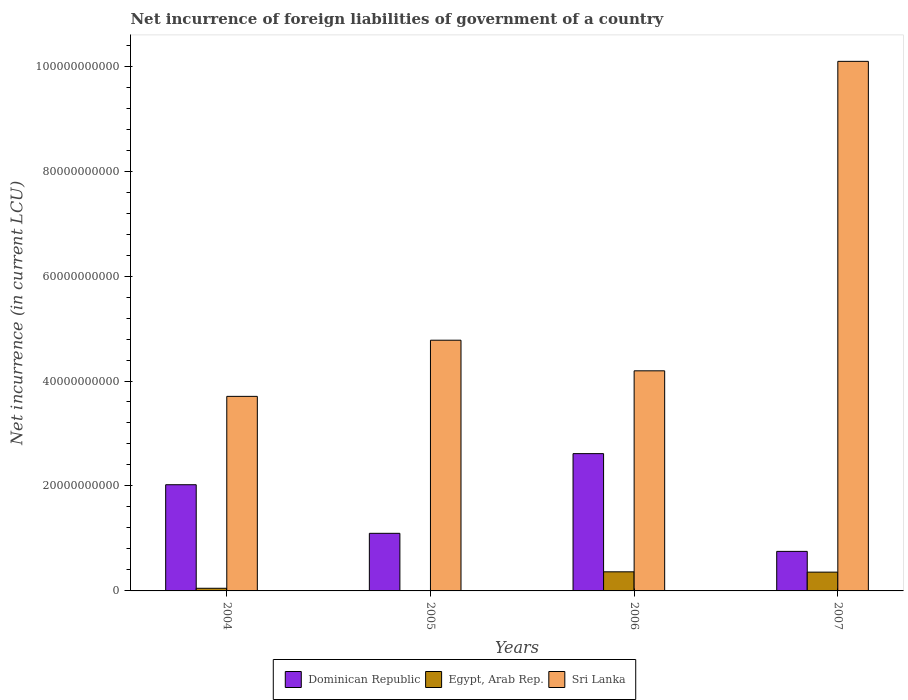How many groups of bars are there?
Your response must be concise. 4. Are the number of bars per tick equal to the number of legend labels?
Offer a very short reply. No. How many bars are there on the 2nd tick from the left?
Give a very brief answer. 2. In how many cases, is the number of bars for a given year not equal to the number of legend labels?
Make the answer very short. 1. What is the net incurrence of foreign liabilities in Dominican Republic in 2005?
Offer a terse response. 1.10e+1. Across all years, what is the maximum net incurrence of foreign liabilities in Dominican Republic?
Give a very brief answer. 2.62e+1. Across all years, what is the minimum net incurrence of foreign liabilities in Sri Lanka?
Provide a succinct answer. 3.71e+1. What is the total net incurrence of foreign liabilities in Dominican Republic in the graph?
Keep it short and to the point. 6.49e+1. What is the difference between the net incurrence of foreign liabilities in Sri Lanka in 2004 and that in 2007?
Offer a terse response. -6.38e+1. What is the difference between the net incurrence of foreign liabilities in Dominican Republic in 2005 and the net incurrence of foreign liabilities in Egypt, Arab Rep. in 2004?
Make the answer very short. 1.05e+1. What is the average net incurrence of foreign liabilities in Egypt, Arab Rep. per year?
Your response must be concise. 1.93e+09. In the year 2005, what is the difference between the net incurrence of foreign liabilities in Sri Lanka and net incurrence of foreign liabilities in Dominican Republic?
Provide a short and direct response. 3.68e+1. What is the ratio of the net incurrence of foreign liabilities in Egypt, Arab Rep. in 2006 to that in 2007?
Your answer should be compact. 1.02. Is the net incurrence of foreign liabilities in Dominican Republic in 2004 less than that in 2006?
Ensure brevity in your answer.  Yes. Is the difference between the net incurrence of foreign liabilities in Sri Lanka in 2005 and 2006 greater than the difference between the net incurrence of foreign liabilities in Dominican Republic in 2005 and 2006?
Offer a very short reply. Yes. What is the difference between the highest and the second highest net incurrence of foreign liabilities in Dominican Republic?
Your response must be concise. 5.93e+09. What is the difference between the highest and the lowest net incurrence of foreign liabilities in Egypt, Arab Rep.?
Offer a very short reply. 3.64e+09. In how many years, is the net incurrence of foreign liabilities in Egypt, Arab Rep. greater than the average net incurrence of foreign liabilities in Egypt, Arab Rep. taken over all years?
Keep it short and to the point. 2. Is the sum of the net incurrence of foreign liabilities in Egypt, Arab Rep. in 2006 and 2007 greater than the maximum net incurrence of foreign liabilities in Dominican Republic across all years?
Your answer should be compact. No. How many bars are there?
Offer a very short reply. 11. Are the values on the major ticks of Y-axis written in scientific E-notation?
Keep it short and to the point. No. Does the graph contain any zero values?
Provide a succinct answer. Yes. Does the graph contain grids?
Your answer should be very brief. No. Where does the legend appear in the graph?
Your answer should be very brief. Bottom center. How are the legend labels stacked?
Offer a terse response. Horizontal. What is the title of the graph?
Your answer should be very brief. Net incurrence of foreign liabilities of government of a country. What is the label or title of the Y-axis?
Your answer should be very brief. Net incurrence (in current LCU). What is the Net incurrence (in current LCU) of Dominican Republic in 2004?
Offer a very short reply. 2.02e+1. What is the Net incurrence (in current LCU) in Egypt, Arab Rep. in 2004?
Offer a very short reply. 5.04e+08. What is the Net incurrence (in current LCU) in Sri Lanka in 2004?
Keep it short and to the point. 3.71e+1. What is the Net incurrence (in current LCU) of Dominican Republic in 2005?
Offer a very short reply. 1.10e+1. What is the Net incurrence (in current LCU) of Egypt, Arab Rep. in 2005?
Provide a short and direct response. 0. What is the Net incurrence (in current LCU) in Sri Lanka in 2005?
Offer a terse response. 4.78e+1. What is the Net incurrence (in current LCU) of Dominican Republic in 2006?
Your response must be concise. 2.62e+1. What is the Net incurrence (in current LCU) in Egypt, Arab Rep. in 2006?
Provide a short and direct response. 3.64e+09. What is the Net incurrence (in current LCU) in Sri Lanka in 2006?
Give a very brief answer. 4.19e+1. What is the Net incurrence (in current LCU) in Dominican Republic in 2007?
Your answer should be very brief. 7.53e+09. What is the Net incurrence (in current LCU) of Egypt, Arab Rep. in 2007?
Make the answer very short. 3.58e+09. What is the Net incurrence (in current LCU) in Sri Lanka in 2007?
Offer a terse response. 1.01e+11. Across all years, what is the maximum Net incurrence (in current LCU) of Dominican Republic?
Your response must be concise. 2.62e+1. Across all years, what is the maximum Net incurrence (in current LCU) in Egypt, Arab Rep.?
Give a very brief answer. 3.64e+09. Across all years, what is the maximum Net incurrence (in current LCU) of Sri Lanka?
Provide a short and direct response. 1.01e+11. Across all years, what is the minimum Net incurrence (in current LCU) in Dominican Republic?
Provide a short and direct response. 7.53e+09. Across all years, what is the minimum Net incurrence (in current LCU) in Egypt, Arab Rep.?
Give a very brief answer. 0. Across all years, what is the minimum Net incurrence (in current LCU) in Sri Lanka?
Offer a very short reply. 3.71e+1. What is the total Net incurrence (in current LCU) in Dominican Republic in the graph?
Provide a short and direct response. 6.49e+1. What is the total Net incurrence (in current LCU) in Egypt, Arab Rep. in the graph?
Make the answer very short. 7.73e+09. What is the total Net incurrence (in current LCU) of Sri Lanka in the graph?
Your answer should be compact. 2.28e+11. What is the difference between the Net incurrence (in current LCU) in Dominican Republic in 2004 and that in 2005?
Offer a very short reply. 9.26e+09. What is the difference between the Net incurrence (in current LCU) of Sri Lanka in 2004 and that in 2005?
Provide a short and direct response. -1.07e+1. What is the difference between the Net incurrence (in current LCU) of Dominican Republic in 2004 and that in 2006?
Offer a terse response. -5.93e+09. What is the difference between the Net incurrence (in current LCU) of Egypt, Arab Rep. in 2004 and that in 2006?
Give a very brief answer. -3.14e+09. What is the difference between the Net incurrence (in current LCU) in Sri Lanka in 2004 and that in 2006?
Give a very brief answer. -4.87e+09. What is the difference between the Net incurrence (in current LCU) of Dominican Republic in 2004 and that in 2007?
Offer a terse response. 1.27e+1. What is the difference between the Net incurrence (in current LCU) of Egypt, Arab Rep. in 2004 and that in 2007?
Give a very brief answer. -3.08e+09. What is the difference between the Net incurrence (in current LCU) in Sri Lanka in 2004 and that in 2007?
Offer a very short reply. -6.38e+1. What is the difference between the Net incurrence (in current LCU) of Dominican Republic in 2005 and that in 2006?
Offer a very short reply. -1.52e+1. What is the difference between the Net incurrence (in current LCU) in Sri Lanka in 2005 and that in 2006?
Your response must be concise. 5.83e+09. What is the difference between the Net incurrence (in current LCU) of Dominican Republic in 2005 and that in 2007?
Your answer should be compact. 3.44e+09. What is the difference between the Net incurrence (in current LCU) in Sri Lanka in 2005 and that in 2007?
Make the answer very short. -5.31e+1. What is the difference between the Net incurrence (in current LCU) in Dominican Republic in 2006 and that in 2007?
Your answer should be very brief. 1.86e+1. What is the difference between the Net incurrence (in current LCU) in Egypt, Arab Rep. in 2006 and that in 2007?
Provide a short and direct response. 6.00e+07. What is the difference between the Net incurrence (in current LCU) of Sri Lanka in 2006 and that in 2007?
Ensure brevity in your answer.  -5.90e+1. What is the difference between the Net incurrence (in current LCU) in Dominican Republic in 2004 and the Net incurrence (in current LCU) in Sri Lanka in 2005?
Your response must be concise. -2.75e+1. What is the difference between the Net incurrence (in current LCU) of Egypt, Arab Rep. in 2004 and the Net incurrence (in current LCU) of Sri Lanka in 2005?
Ensure brevity in your answer.  -4.73e+1. What is the difference between the Net incurrence (in current LCU) in Dominican Republic in 2004 and the Net incurrence (in current LCU) in Egypt, Arab Rep. in 2006?
Provide a succinct answer. 1.66e+1. What is the difference between the Net incurrence (in current LCU) of Dominican Republic in 2004 and the Net incurrence (in current LCU) of Sri Lanka in 2006?
Provide a short and direct response. -2.17e+1. What is the difference between the Net incurrence (in current LCU) in Egypt, Arab Rep. in 2004 and the Net incurrence (in current LCU) in Sri Lanka in 2006?
Keep it short and to the point. -4.14e+1. What is the difference between the Net incurrence (in current LCU) of Dominican Republic in 2004 and the Net incurrence (in current LCU) of Egypt, Arab Rep. in 2007?
Your response must be concise. 1.67e+1. What is the difference between the Net incurrence (in current LCU) in Dominican Republic in 2004 and the Net incurrence (in current LCU) in Sri Lanka in 2007?
Provide a short and direct response. -8.07e+1. What is the difference between the Net incurrence (in current LCU) of Egypt, Arab Rep. in 2004 and the Net incurrence (in current LCU) of Sri Lanka in 2007?
Ensure brevity in your answer.  -1.00e+11. What is the difference between the Net incurrence (in current LCU) of Dominican Republic in 2005 and the Net incurrence (in current LCU) of Egypt, Arab Rep. in 2006?
Provide a succinct answer. 7.34e+09. What is the difference between the Net incurrence (in current LCU) of Dominican Republic in 2005 and the Net incurrence (in current LCU) of Sri Lanka in 2006?
Your response must be concise. -3.10e+1. What is the difference between the Net incurrence (in current LCU) in Dominican Republic in 2005 and the Net incurrence (in current LCU) in Egypt, Arab Rep. in 2007?
Give a very brief answer. 7.40e+09. What is the difference between the Net incurrence (in current LCU) in Dominican Republic in 2005 and the Net incurrence (in current LCU) in Sri Lanka in 2007?
Provide a short and direct response. -8.99e+1. What is the difference between the Net incurrence (in current LCU) of Dominican Republic in 2006 and the Net incurrence (in current LCU) of Egypt, Arab Rep. in 2007?
Offer a very short reply. 2.26e+1. What is the difference between the Net incurrence (in current LCU) of Dominican Republic in 2006 and the Net incurrence (in current LCU) of Sri Lanka in 2007?
Your answer should be compact. -7.47e+1. What is the difference between the Net incurrence (in current LCU) in Egypt, Arab Rep. in 2006 and the Net incurrence (in current LCU) in Sri Lanka in 2007?
Your response must be concise. -9.73e+1. What is the average Net incurrence (in current LCU) of Dominican Republic per year?
Give a very brief answer. 1.62e+1. What is the average Net incurrence (in current LCU) in Egypt, Arab Rep. per year?
Your answer should be compact. 1.93e+09. What is the average Net incurrence (in current LCU) of Sri Lanka per year?
Offer a terse response. 5.69e+1. In the year 2004, what is the difference between the Net incurrence (in current LCU) in Dominican Republic and Net incurrence (in current LCU) in Egypt, Arab Rep.?
Keep it short and to the point. 1.97e+1. In the year 2004, what is the difference between the Net incurrence (in current LCU) of Dominican Republic and Net incurrence (in current LCU) of Sri Lanka?
Your answer should be compact. -1.68e+1. In the year 2004, what is the difference between the Net incurrence (in current LCU) of Egypt, Arab Rep. and Net incurrence (in current LCU) of Sri Lanka?
Your answer should be compact. -3.66e+1. In the year 2005, what is the difference between the Net incurrence (in current LCU) in Dominican Republic and Net incurrence (in current LCU) in Sri Lanka?
Keep it short and to the point. -3.68e+1. In the year 2006, what is the difference between the Net incurrence (in current LCU) of Dominican Republic and Net incurrence (in current LCU) of Egypt, Arab Rep.?
Your answer should be compact. 2.25e+1. In the year 2006, what is the difference between the Net incurrence (in current LCU) in Dominican Republic and Net incurrence (in current LCU) in Sri Lanka?
Offer a terse response. -1.58e+1. In the year 2006, what is the difference between the Net incurrence (in current LCU) in Egypt, Arab Rep. and Net incurrence (in current LCU) in Sri Lanka?
Your response must be concise. -3.83e+1. In the year 2007, what is the difference between the Net incurrence (in current LCU) in Dominican Republic and Net incurrence (in current LCU) in Egypt, Arab Rep.?
Offer a very short reply. 3.95e+09. In the year 2007, what is the difference between the Net incurrence (in current LCU) in Dominican Republic and Net incurrence (in current LCU) in Sri Lanka?
Ensure brevity in your answer.  -9.34e+1. In the year 2007, what is the difference between the Net incurrence (in current LCU) in Egypt, Arab Rep. and Net incurrence (in current LCU) in Sri Lanka?
Your answer should be very brief. -9.73e+1. What is the ratio of the Net incurrence (in current LCU) in Dominican Republic in 2004 to that in 2005?
Your answer should be compact. 1.84. What is the ratio of the Net incurrence (in current LCU) in Sri Lanka in 2004 to that in 2005?
Keep it short and to the point. 0.78. What is the ratio of the Net incurrence (in current LCU) of Dominican Republic in 2004 to that in 2006?
Provide a short and direct response. 0.77. What is the ratio of the Net incurrence (in current LCU) in Egypt, Arab Rep. in 2004 to that in 2006?
Offer a terse response. 0.14. What is the ratio of the Net incurrence (in current LCU) in Sri Lanka in 2004 to that in 2006?
Ensure brevity in your answer.  0.88. What is the ratio of the Net incurrence (in current LCU) of Dominican Republic in 2004 to that in 2007?
Make the answer very short. 2.69. What is the ratio of the Net incurrence (in current LCU) in Egypt, Arab Rep. in 2004 to that in 2007?
Your answer should be compact. 0.14. What is the ratio of the Net incurrence (in current LCU) in Sri Lanka in 2004 to that in 2007?
Offer a terse response. 0.37. What is the ratio of the Net incurrence (in current LCU) of Dominican Republic in 2005 to that in 2006?
Your answer should be compact. 0.42. What is the ratio of the Net incurrence (in current LCU) of Sri Lanka in 2005 to that in 2006?
Ensure brevity in your answer.  1.14. What is the ratio of the Net incurrence (in current LCU) in Dominican Republic in 2005 to that in 2007?
Make the answer very short. 1.46. What is the ratio of the Net incurrence (in current LCU) of Sri Lanka in 2005 to that in 2007?
Ensure brevity in your answer.  0.47. What is the ratio of the Net incurrence (in current LCU) in Dominican Republic in 2006 to that in 2007?
Your answer should be very brief. 3.47. What is the ratio of the Net incurrence (in current LCU) in Egypt, Arab Rep. in 2006 to that in 2007?
Your answer should be compact. 1.02. What is the ratio of the Net incurrence (in current LCU) in Sri Lanka in 2006 to that in 2007?
Ensure brevity in your answer.  0.42. What is the difference between the highest and the second highest Net incurrence (in current LCU) in Dominican Republic?
Provide a succinct answer. 5.93e+09. What is the difference between the highest and the second highest Net incurrence (in current LCU) in Egypt, Arab Rep.?
Offer a terse response. 6.00e+07. What is the difference between the highest and the second highest Net incurrence (in current LCU) in Sri Lanka?
Your answer should be very brief. 5.31e+1. What is the difference between the highest and the lowest Net incurrence (in current LCU) in Dominican Republic?
Offer a very short reply. 1.86e+1. What is the difference between the highest and the lowest Net incurrence (in current LCU) of Egypt, Arab Rep.?
Offer a terse response. 3.64e+09. What is the difference between the highest and the lowest Net incurrence (in current LCU) in Sri Lanka?
Provide a succinct answer. 6.38e+1. 